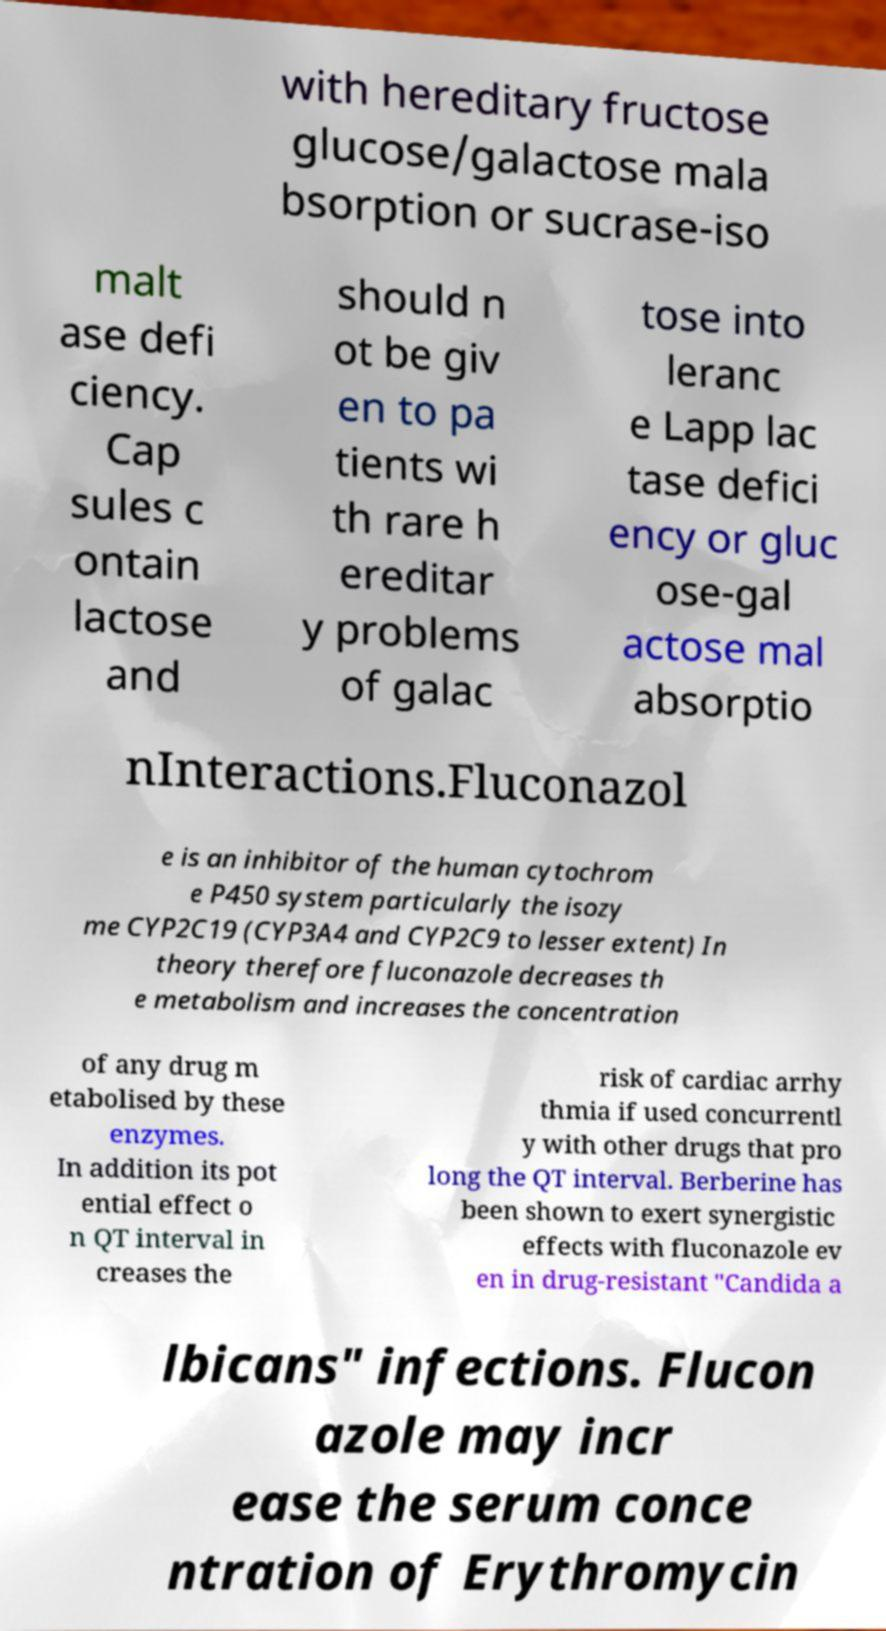I need the written content from this picture converted into text. Can you do that? with hereditary fructose glucose/galactose mala bsorption or sucrase-iso malt ase defi ciency. Cap sules c ontain lactose and should n ot be giv en to pa tients wi th rare h ereditar y problems of galac tose into leranc e Lapp lac tase defici ency or gluc ose-gal actose mal absorptio nInteractions.Fluconazol e is an inhibitor of the human cytochrom e P450 system particularly the isozy me CYP2C19 (CYP3A4 and CYP2C9 to lesser extent) In theory therefore fluconazole decreases th e metabolism and increases the concentration of any drug m etabolised by these enzymes. In addition its pot ential effect o n QT interval in creases the risk of cardiac arrhy thmia if used concurrentl y with other drugs that pro long the QT interval. Berberine has been shown to exert synergistic effects with fluconazole ev en in drug-resistant "Candida a lbicans" infections. Flucon azole may incr ease the serum conce ntration of Erythromycin 